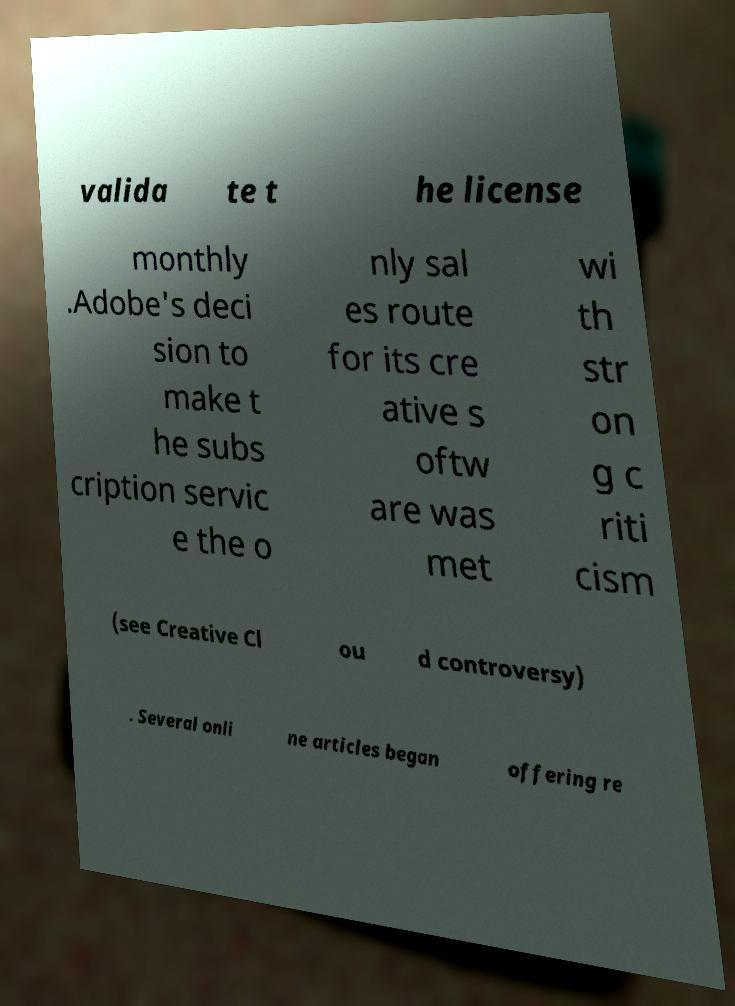Can you read and provide the text displayed in the image?This photo seems to have some interesting text. Can you extract and type it out for me? valida te t he license monthly .Adobe's deci sion to make t he subs cription servic e the o nly sal es route for its cre ative s oftw are was met wi th str on g c riti cism (see Creative Cl ou d controversy) . Several onli ne articles began offering re 